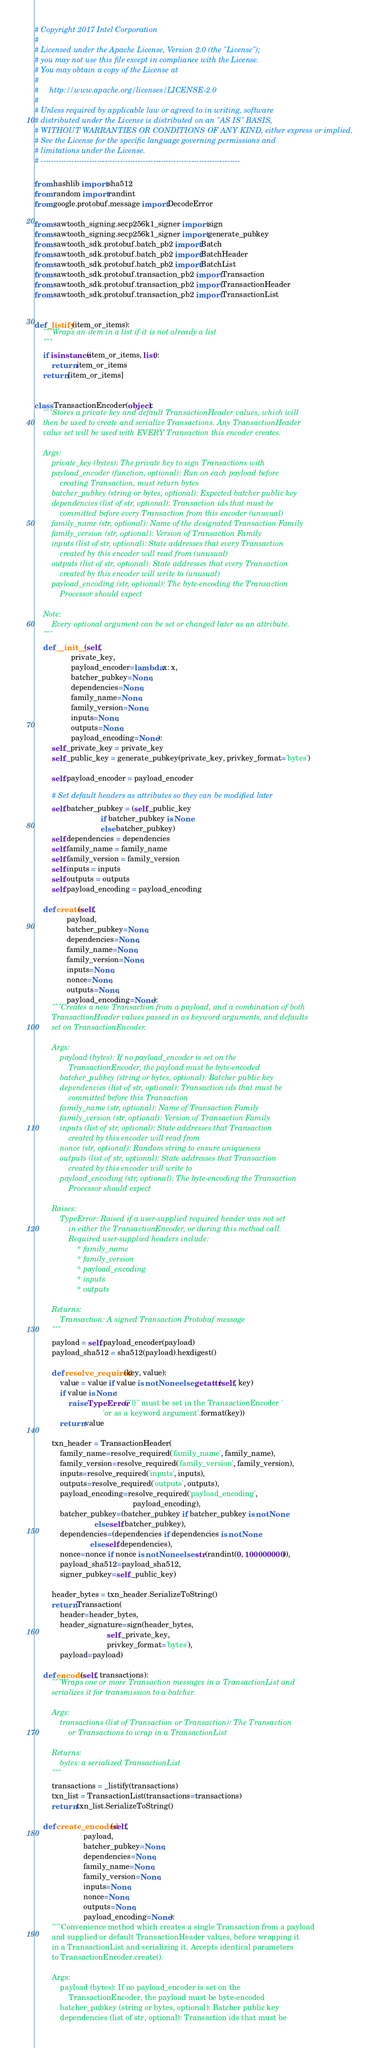Convert code to text. <code><loc_0><loc_0><loc_500><loc_500><_Python_># Copyright 2017 Intel Corporation
#
# Licensed under the Apache License, Version 2.0 (the "License");
# you may not use this file except in compliance with the License.
# You may obtain a copy of the License at
#
#     http://www.apache.org/licenses/LICENSE-2.0
#
# Unless required by applicable law or agreed to in writing, software
# distributed under the License is distributed on an "AS IS" BASIS,
# WITHOUT WARRANTIES OR CONDITIONS OF ANY KIND, either express or implied.
# See the License for the specific language governing permissions and
# limitations under the License.
# ------------------------------------------------------------------------------

from hashlib import sha512
from random import randint
from google.protobuf.message import DecodeError

from sawtooth_signing.secp256k1_signer import sign
from sawtooth_signing.secp256k1_signer import generate_pubkey
from sawtooth_sdk.protobuf.batch_pb2 import Batch
from sawtooth_sdk.protobuf.batch_pb2 import BatchHeader
from sawtooth_sdk.protobuf.batch_pb2 import BatchList
from sawtooth_sdk.protobuf.transaction_pb2 import Transaction
from sawtooth_sdk.protobuf.transaction_pb2 import TransactionHeader
from sawtooth_sdk.protobuf.transaction_pb2 import TransactionList


def _listify(item_or_items):
    """Wraps an item in a list if it is not already a list
    """
    if isinstance(item_or_items, list):
        return item_or_items
    return [item_or_items]


class TransactionEncoder(object):
    """Stores a private key and default TransactionHeader values, which will
    then be used to create and serialize Transactions. Any TransactionHeader
    value set will be used with EVERY Transaction this encoder creates.

    Args:
        private_key (bytes): The private key to sign Transactions with
        payload_encoder (function, optional): Run on each payload before
            creating Transaction, must return bytes
        batcher_pubkey (string or bytes, optional): Expected batcher public key
        dependencies (list of str, optional): Transaction ids that must be
            committed before every Transaction from this encoder (unusual)
        family_name (str, optional): Name of the designated Transaction Family
        family_version (str, optional): Version of Transaction Family
        inputs (list of str, optional): State addresses that every Transaction
            created by this encoder will read from (unusual)
        outputs (list of str, optional): State addresses that every Transaction
            created by this encoder will write to (unusual)
        payload_encoding (str, optional): The byte-encoding the Transaction
            Processor should expect

    Note:
        Every optional argument can be set or changed later as an attribute.
    """
    def __init__(self,
                 private_key,
                 payload_encoder=lambda x: x,
                 batcher_pubkey=None,
                 dependencies=None,
                 family_name=None,
                 family_version=None,
                 inputs=None,
                 outputs=None,
                 payload_encoding=None):
        self._private_key = private_key
        self._public_key = generate_pubkey(private_key, privkey_format='bytes')

        self.payload_encoder = payload_encoder

        # Set default headers as attributes so they can be modified later
        self.batcher_pubkey = (self._public_key
                               if batcher_pubkey is None
                               else batcher_pubkey)
        self.dependencies = dependencies
        self.family_name = family_name
        self.family_version = family_version
        self.inputs = inputs
        self.outputs = outputs
        self.payload_encoding = payload_encoding

    def create(self,
               payload,
               batcher_pubkey=None,
               dependencies=None,
               family_name=None,
               family_version=None,
               inputs=None,
               nonce=None,
               outputs=None,
               payload_encoding=None):
        """Creates a new Transaction from a payload, and a combination of both
        TransactionHeader values passed in as keyword arguments, and defaults
        set on TransactionEncoder.

        Args:
            payload (bytes): If no payload_encoder is set on the
                TransactionEncoder, the payload must be byte-encoded
            batcher_pubkey (string or bytes, optional): Batcher public key
            dependencies (list of str, optional): Transaction ids that must be
                committed before this Transaction
            family_name (str, optional): Name of Transaction Family
            family_version (str, optional): Version of Transaction Family
            inputs (list of str, optional): State addresses that Transaction
                created by this encoder will read from
            nonce (str, optional): Random string to ensure uniqueness
            outputs (list of str, optional): State addresses that Transaction
                created by this encoder will write to
            payload_encoding (str, optional): The byte-encoding the Transaction
                Processor should expect

        Raises:
            TypeError: Raised if a user-supplied required header was not set
                in either the TransactionEncoder, or during this method call.
                Required user-supplied headers include:
                    * family_name
                    * family_version
                    * payload_encoding
                    * inputs
                    * outputs

        Returns:
            Transaction: A signed Transaction Protobuf message
        """
        payload = self.payload_encoder(payload)
        payload_sha512 = sha512(payload).hexdigest()

        def resolve_required(key, value):
            value = value if value is not None else getattr(self, key)
            if value is None:
                raise TypeError('"{}" must be set in the TransactionEncoder '
                                'or as a keyword argument'.format(key))
            return value

        txn_header = TransactionHeader(
            family_name=resolve_required('family_name', family_name),
            family_version=resolve_required('family_version', family_version),
            inputs=resolve_required('inputs', inputs),
            outputs=resolve_required('outputs', outputs),
            payload_encoding=resolve_required('payload_encoding',
                                              payload_encoding),
            batcher_pubkey=(batcher_pubkey if batcher_pubkey is not None
                            else self.batcher_pubkey),
            dependencies=(dependencies if dependencies is not None
                          else self.dependencies),
            nonce=nonce if nonce is not None else str(randint(0, 100000000)),
            payload_sha512=payload_sha512,
            signer_pubkey=self._public_key)

        header_bytes = txn_header.SerializeToString()
        return Transaction(
            header=header_bytes,
            header_signature=sign(header_bytes,
                                  self._private_key,
                                  privkey_format='bytes'),
            payload=payload)

    def encode(self, transactions):
        """Wraps one or more Transaction messages in a TransactionList and
        serializes it for transmission to a batcher.

        Args:
            transactions (list of Transaction or Transaction): The Transaction
                or Transactions to wrap in a TransactionList

        Returns:
            bytes: a serialized TransactionList
        """
        transactions = _listify(transactions)
        txn_list = TransactionList(transactions=transactions)
        return txn_list.SerializeToString()

    def create_encoded(self,
                       payload,
                       batcher_pubkey=None,
                       dependencies=None,
                       family_name=None,
                       family_version=None,
                       inputs=None,
                       nonce=None,
                       outputs=None,
                       payload_encoding=None):
        """Convenience method which creates a single Transaction from a payload
        and supplied or default TransactionHeader values, before wrapping it
        in a TransactionList and serializing it. Accepts identical parameters
        to TransactionEncoder.create().

        Args:
            payload (bytes): If no payload_encoder is set on the
                TransactionEncoder, the payload must be byte-encoded
            batcher_pubkey (string or bytes, optional): Batcher public key
            dependencies (list of str, optional): Transaction ids that must be</code> 